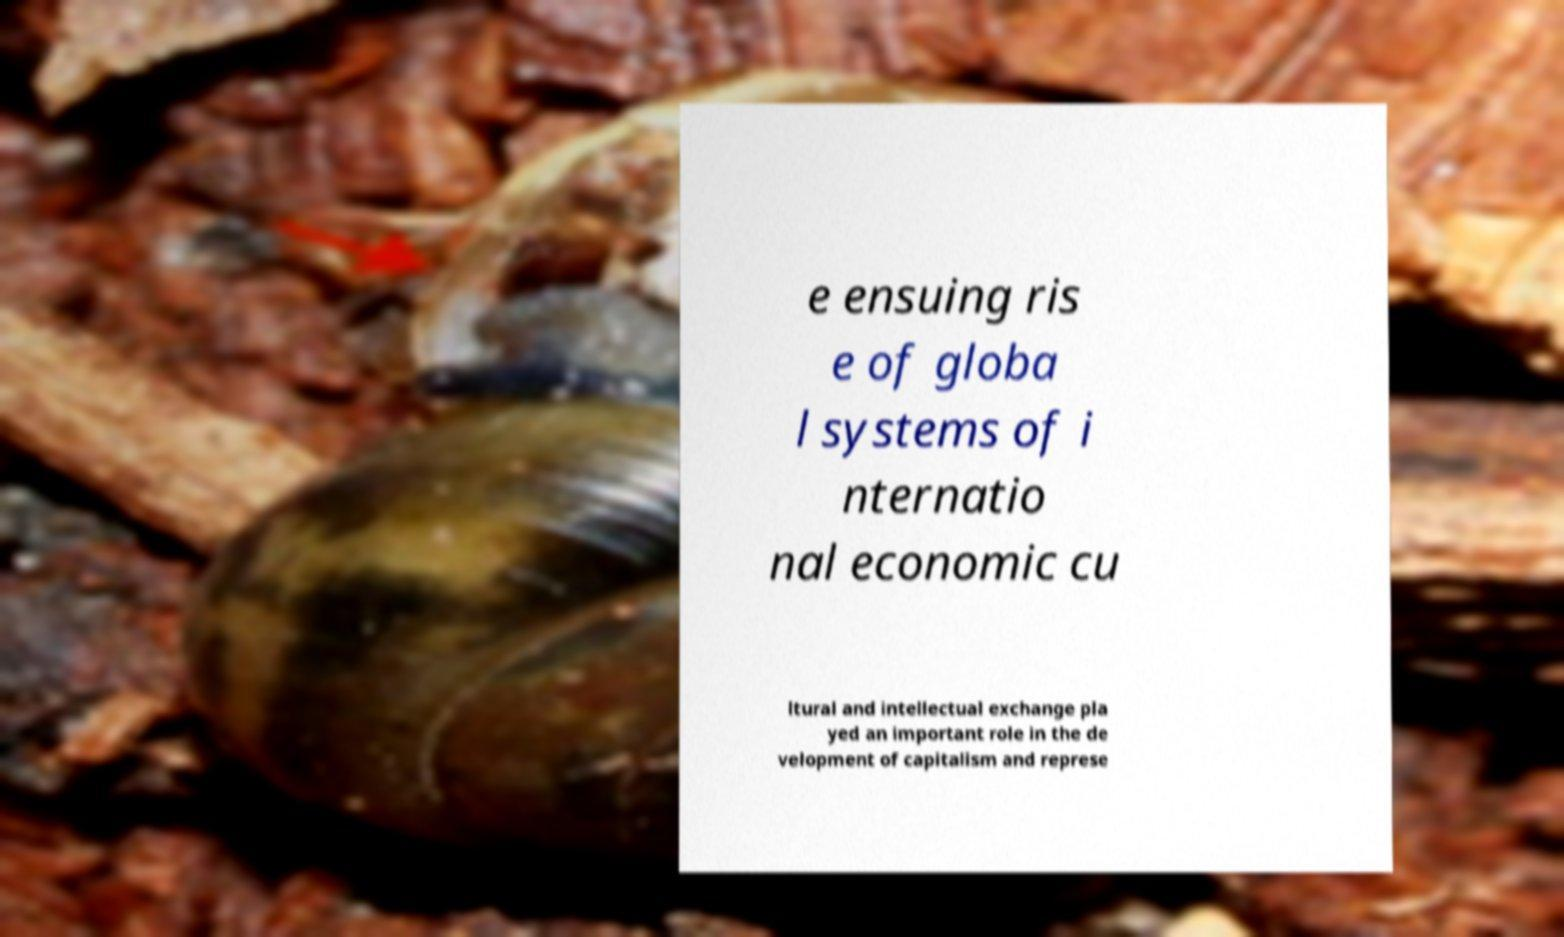Could you extract and type out the text from this image? e ensuing ris e of globa l systems of i nternatio nal economic cu ltural and intellectual exchange pla yed an important role in the de velopment of capitalism and represe 